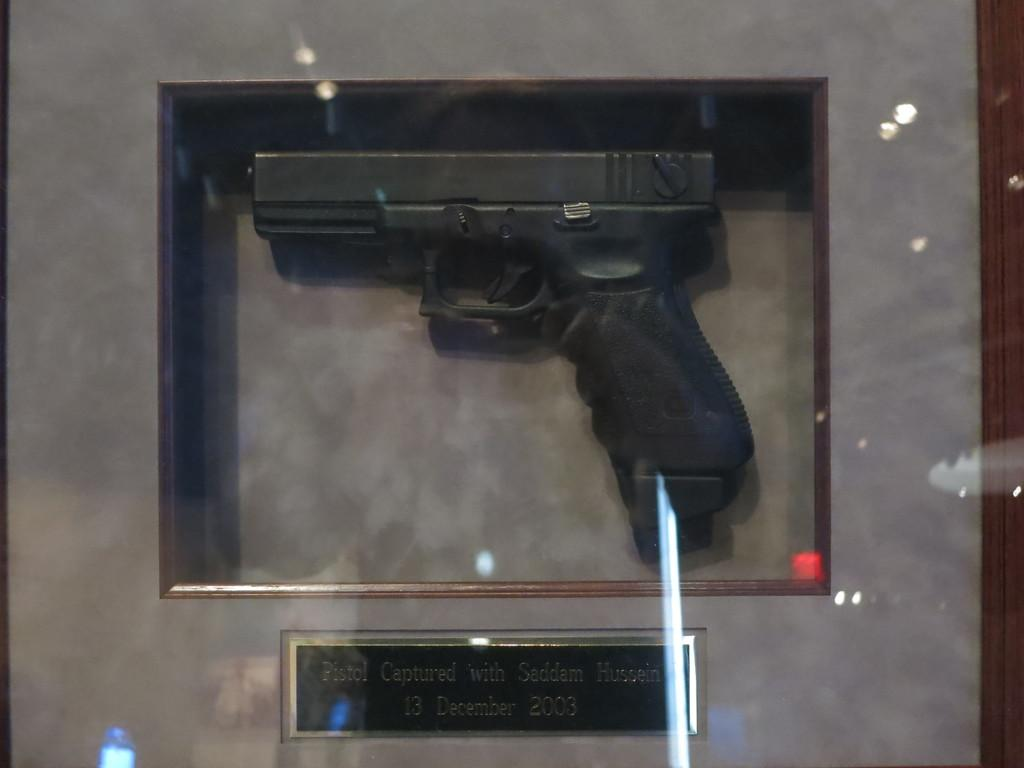What object is the main focus of the image? There is a gun in the image. How is the gun displayed in the image? The gun is inside a glass box. What other object is present in the image besides the gun? There is a board with text in the image. What type of print can be seen on the gun in the image? There is no print visible on the gun in the image; it is inside a glass box. How many circles are present on the board with text in the image? There is no mention of circles on the board with text in the image; it only contains text. 